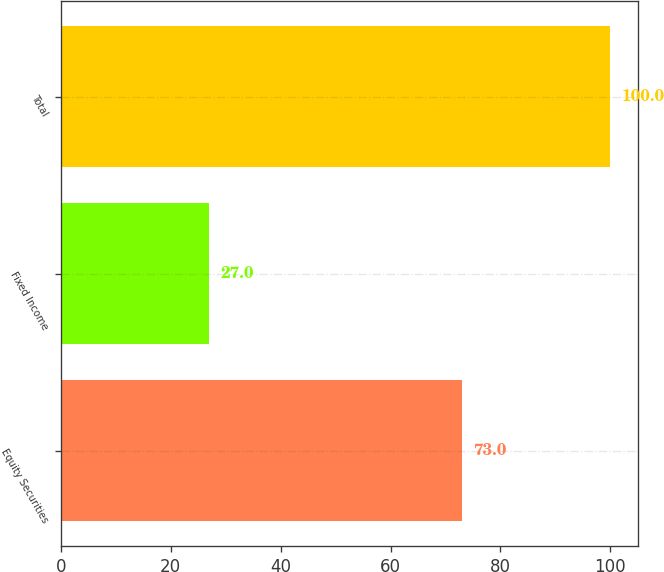<chart> <loc_0><loc_0><loc_500><loc_500><bar_chart><fcel>Equity Securities<fcel>Fixed Income<fcel>Total<nl><fcel>73<fcel>27<fcel>100<nl></chart> 